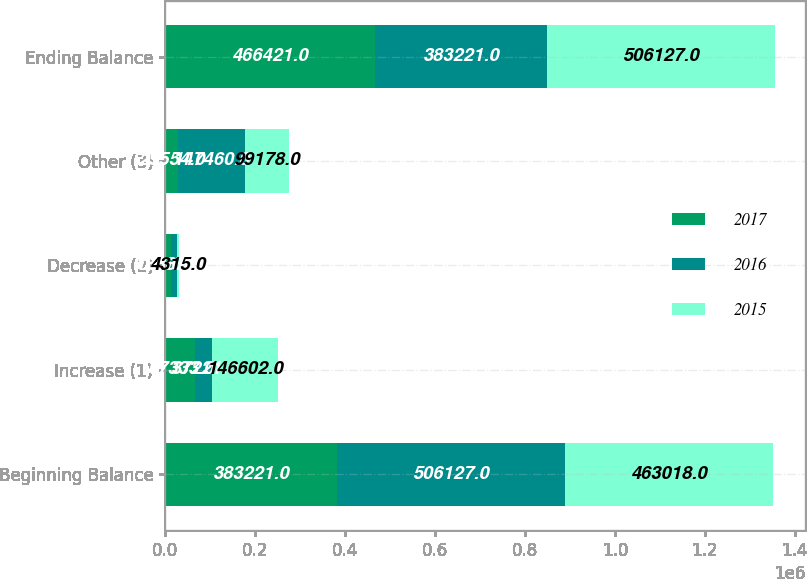Convert chart to OTSL. <chart><loc_0><loc_0><loc_500><loc_500><stacked_bar_chart><ecel><fcel>Beginning Balance<fcel>Increase (1)<fcel>Decrease (2)<fcel>Other (3)<fcel>Ending Balance<nl><fcel>2017<fcel>383221<fcel>67333<fcel>13687<fcel>29554<fcel>466421<nl><fcel>2016<fcel>506127<fcel>37221<fcel>12667<fcel>147460<fcel>383221<nl><fcel>2015<fcel>463018<fcel>146602<fcel>4315<fcel>99178<fcel>506127<nl></chart> 